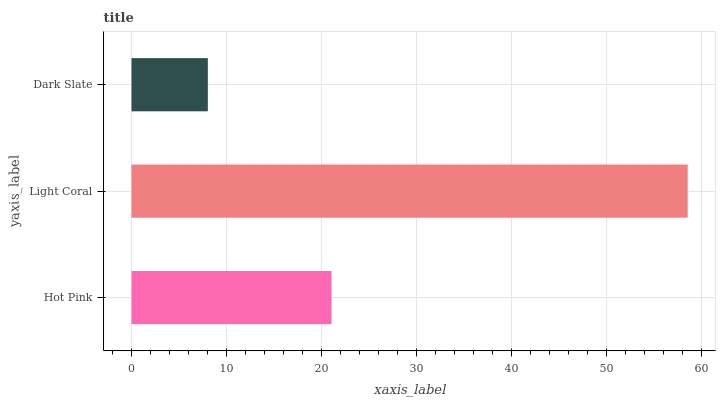Is Dark Slate the minimum?
Answer yes or no. Yes. Is Light Coral the maximum?
Answer yes or no. Yes. Is Light Coral the minimum?
Answer yes or no. No. Is Dark Slate the maximum?
Answer yes or no. No. Is Light Coral greater than Dark Slate?
Answer yes or no. Yes. Is Dark Slate less than Light Coral?
Answer yes or no. Yes. Is Dark Slate greater than Light Coral?
Answer yes or no. No. Is Light Coral less than Dark Slate?
Answer yes or no. No. Is Hot Pink the high median?
Answer yes or no. Yes. Is Hot Pink the low median?
Answer yes or no. Yes. Is Light Coral the high median?
Answer yes or no. No. Is Light Coral the low median?
Answer yes or no. No. 